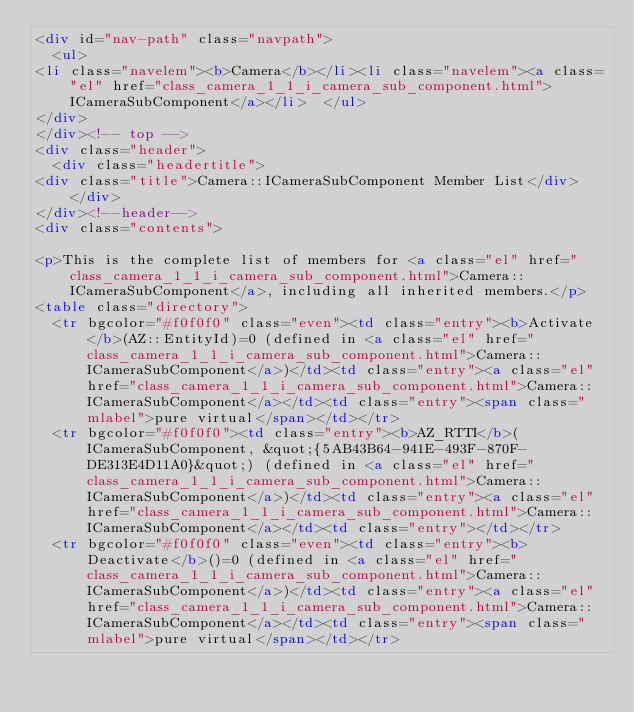Convert code to text. <code><loc_0><loc_0><loc_500><loc_500><_HTML_><div id="nav-path" class="navpath">
  <ul>
<li class="navelem"><b>Camera</b></li><li class="navelem"><a class="el" href="class_camera_1_1_i_camera_sub_component.html">ICameraSubComponent</a></li>  </ul>
</div>
</div><!-- top -->
<div class="header">
  <div class="headertitle">
<div class="title">Camera::ICameraSubComponent Member List</div>  </div>
</div><!--header-->
<div class="contents">

<p>This is the complete list of members for <a class="el" href="class_camera_1_1_i_camera_sub_component.html">Camera::ICameraSubComponent</a>, including all inherited members.</p>
<table class="directory">
  <tr bgcolor="#f0f0f0" class="even"><td class="entry"><b>Activate</b>(AZ::EntityId)=0 (defined in <a class="el" href="class_camera_1_1_i_camera_sub_component.html">Camera::ICameraSubComponent</a>)</td><td class="entry"><a class="el" href="class_camera_1_1_i_camera_sub_component.html">Camera::ICameraSubComponent</a></td><td class="entry"><span class="mlabel">pure virtual</span></td></tr>
  <tr bgcolor="#f0f0f0"><td class="entry"><b>AZ_RTTI</b>(ICameraSubComponent, &quot;{5AB43B64-941E-493F-870F-DE313E4D11A0}&quot;) (defined in <a class="el" href="class_camera_1_1_i_camera_sub_component.html">Camera::ICameraSubComponent</a>)</td><td class="entry"><a class="el" href="class_camera_1_1_i_camera_sub_component.html">Camera::ICameraSubComponent</a></td><td class="entry"></td></tr>
  <tr bgcolor="#f0f0f0" class="even"><td class="entry"><b>Deactivate</b>()=0 (defined in <a class="el" href="class_camera_1_1_i_camera_sub_component.html">Camera::ICameraSubComponent</a>)</td><td class="entry"><a class="el" href="class_camera_1_1_i_camera_sub_component.html">Camera::ICameraSubComponent</a></td><td class="entry"><span class="mlabel">pure virtual</span></td></tr></code> 